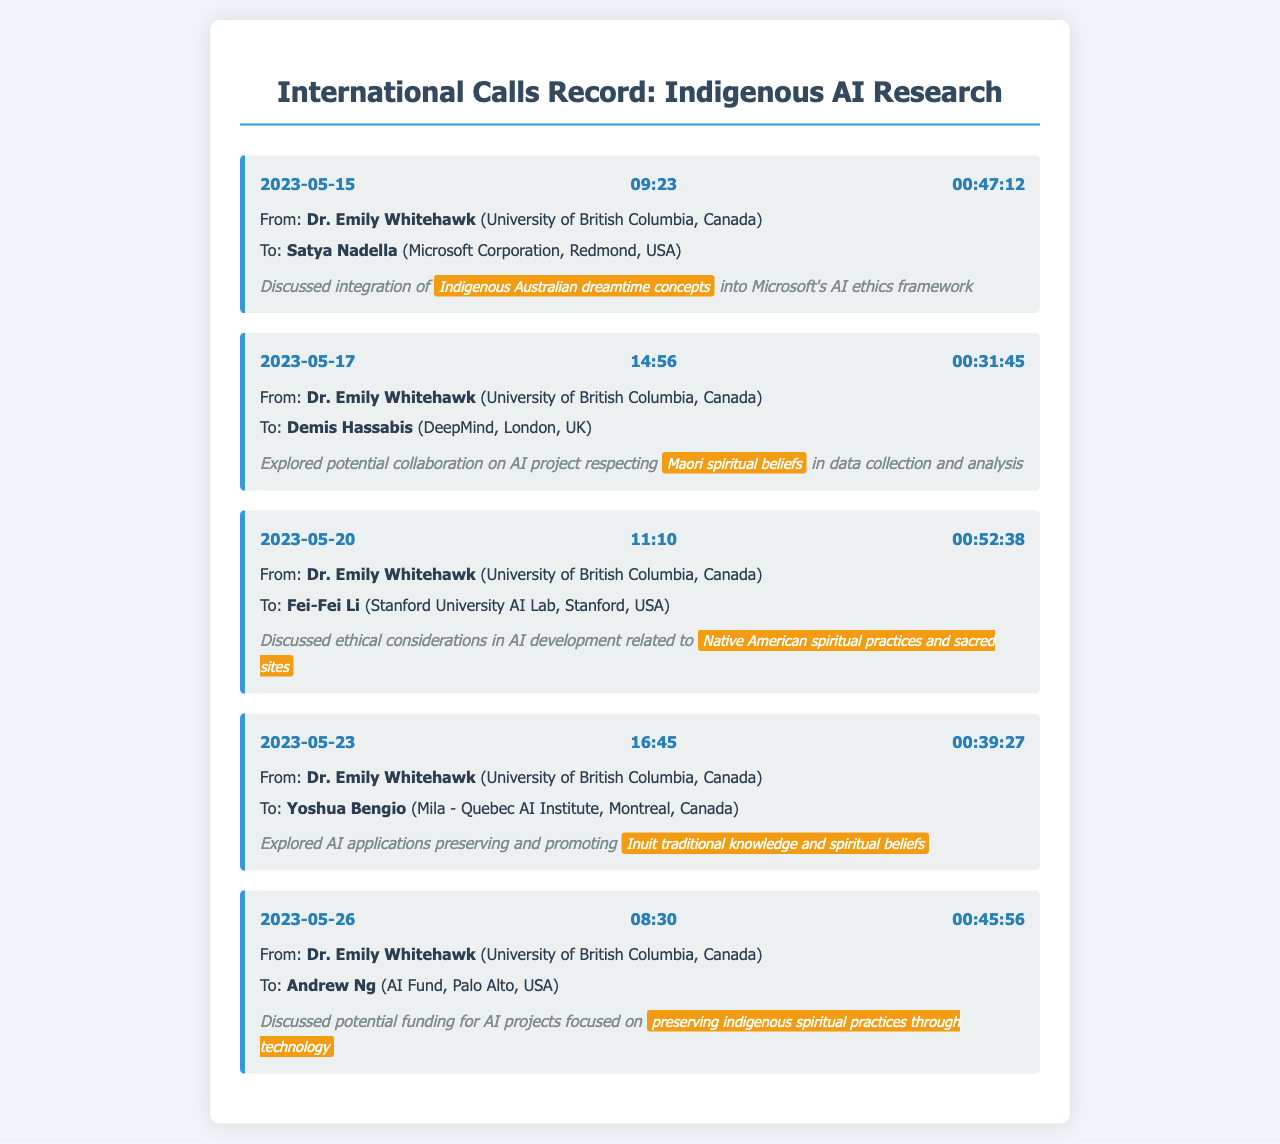What is the date of the first call? The date of the first call in the document is listed in the first call record.
Answer: 2023-05-15 Who is the recipient of the call on May 20, 2023? The recipient of the call on May 20, 2023, can be found in the corresponding call record.
Answer: Fei-Fei Li How long was the call with Andrew Ng? The duration of the call with Andrew Ng is specified in the call record for that date.
Answer: 00:45:56 What concept was discussed with Satya Nadella? The discussion topic for the call with Satya Nadella is mentioned in the call notes of that record.
Answer: Indigenous Australian dreamtime concepts Which organization is associated with Yoshua Bengio? The document lists the recipient and their associated organization in the call record for that date.
Answer: Mila - Quebec AI Institute How many calls were made by Dr. Emily Whitehawk in May 2023? The number of calls made can be counted from the entries in the month of May 2023.
Answer: Five What was a focus area for the discussion with DeepMind? The focus area for the call with DeepMind is included in the call notes of that record.
Answer: Maori spiritual beliefs What type of projects was discussed with Andrew Ng? The specific projects discussed with Andrew Ng are stated in the call notes.
Answer: Preserving indigenous spiritual practices through technology What is Dr. Emily Whitehawk's affiliation? Dr. Emily Whitehawk's affiliation is mentioned in each call record.
Answer: University of British Columbia, Canada 